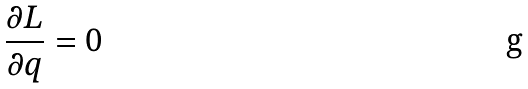<formula> <loc_0><loc_0><loc_500><loc_500>\frac { \partial L } { \partial q } = 0</formula> 